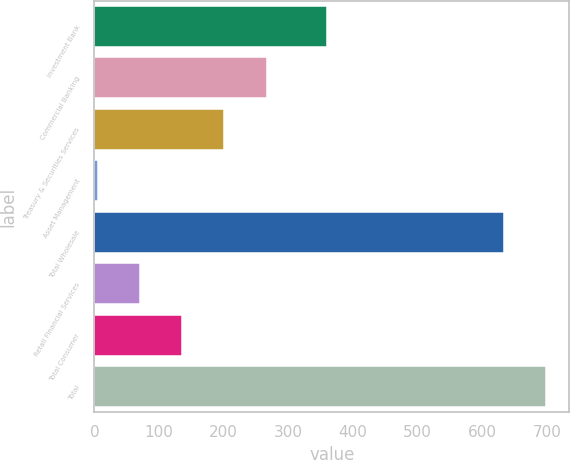Convert chart to OTSL. <chart><loc_0><loc_0><loc_500><loc_500><bar_chart><fcel>Investment Bank<fcel>Commercial Banking<fcel>Treasury & Securities Services<fcel>Asset Management<fcel>Total Wholesale<fcel>Retail Financial Services<fcel>Total Consumer<fcel>Total<nl><fcel>360<fcel>266.6<fcel>201.2<fcel>5<fcel>634<fcel>70.4<fcel>135.8<fcel>699.4<nl></chart> 